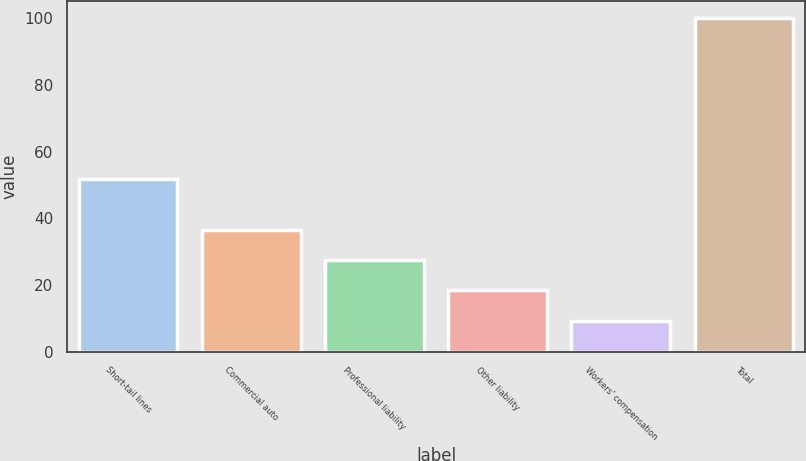<chart> <loc_0><loc_0><loc_500><loc_500><bar_chart><fcel>Short-tail lines<fcel>Commercial auto<fcel>Professional liability<fcel>Other liability<fcel>Workers' compensation<fcel>Total<nl><fcel>51.8<fcel>36.58<fcel>27.52<fcel>18.46<fcel>9.4<fcel>100<nl></chart> 